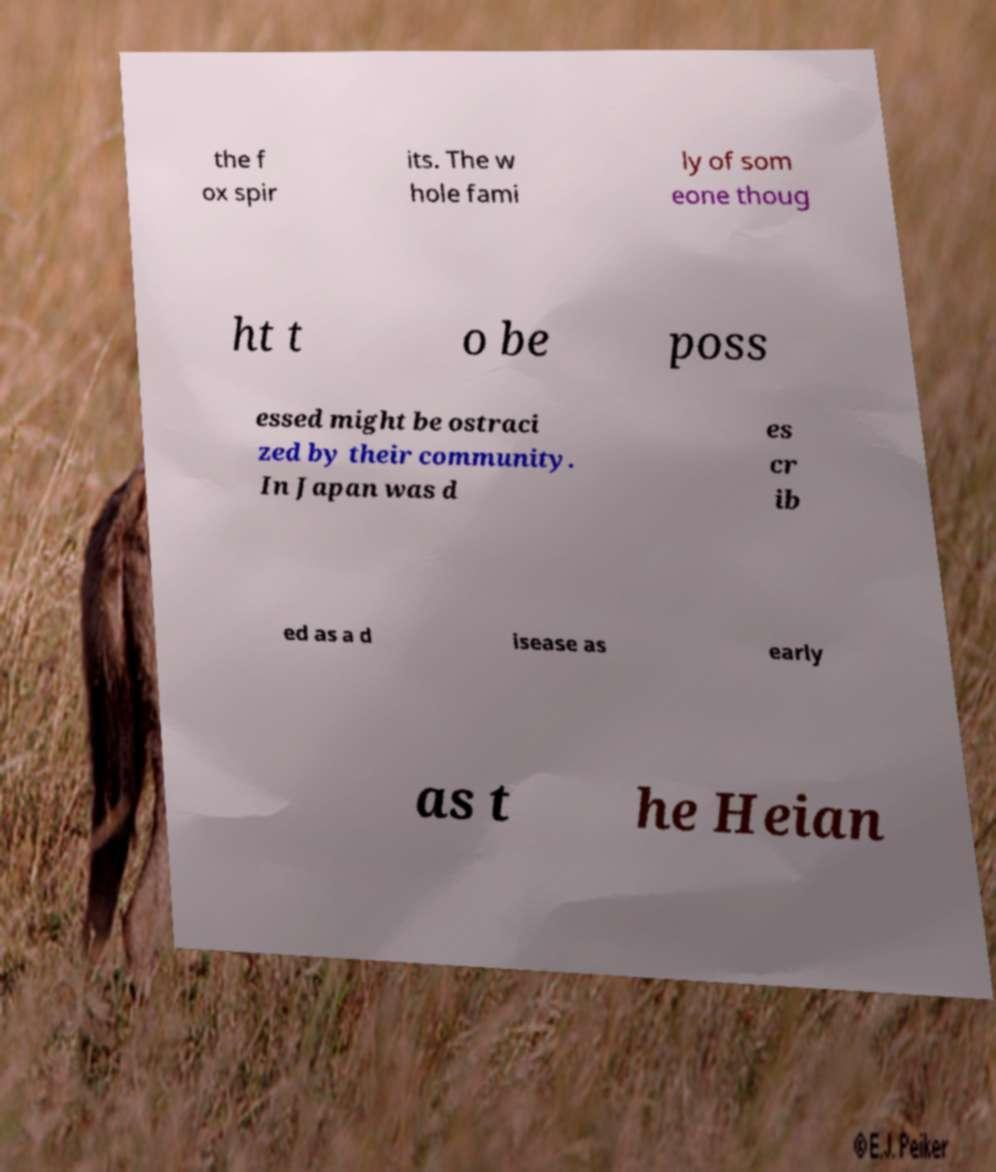I need the written content from this picture converted into text. Can you do that? the f ox spir its. The w hole fami ly of som eone thoug ht t o be poss essed might be ostraci zed by their community. In Japan was d es cr ib ed as a d isease as early as t he Heian 